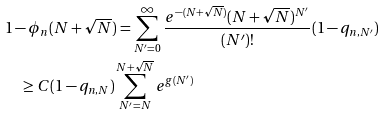Convert formula to latex. <formula><loc_0><loc_0><loc_500><loc_500>& 1 - \phi _ { n } ( N + \sqrt { N } ) = \sum _ { N ^ { \prime } = 0 } ^ { \infty } \frac { e ^ { - ( N + \sqrt { N } ) } ( N + \sqrt { N } ) ^ { N ^ { \prime } } } { ( N ^ { \prime } ) ! } ( 1 - q _ { n , N ^ { \prime } } ) \\ & \quad \geq C ( 1 - q _ { n , N } ) \sum _ { N ^ { \prime } = N } ^ { N + \sqrt { N } } e ^ { g ( N ^ { \prime } ) }</formula> 